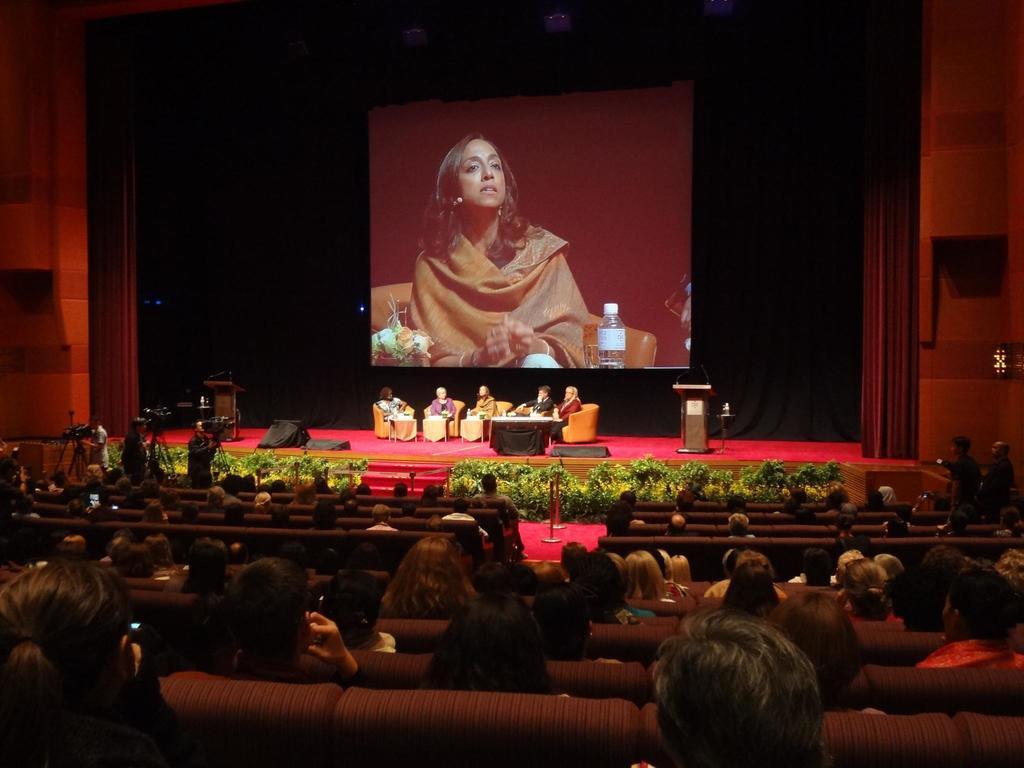Who is present in the image? There are people in the image. What are the people doing in the image? The people are sitting. What are the people looking at while sitting? The people are looking at a screen. What type of road can be seen in the image? There is no road present in the image; it features people sitting and looking at a screen. 